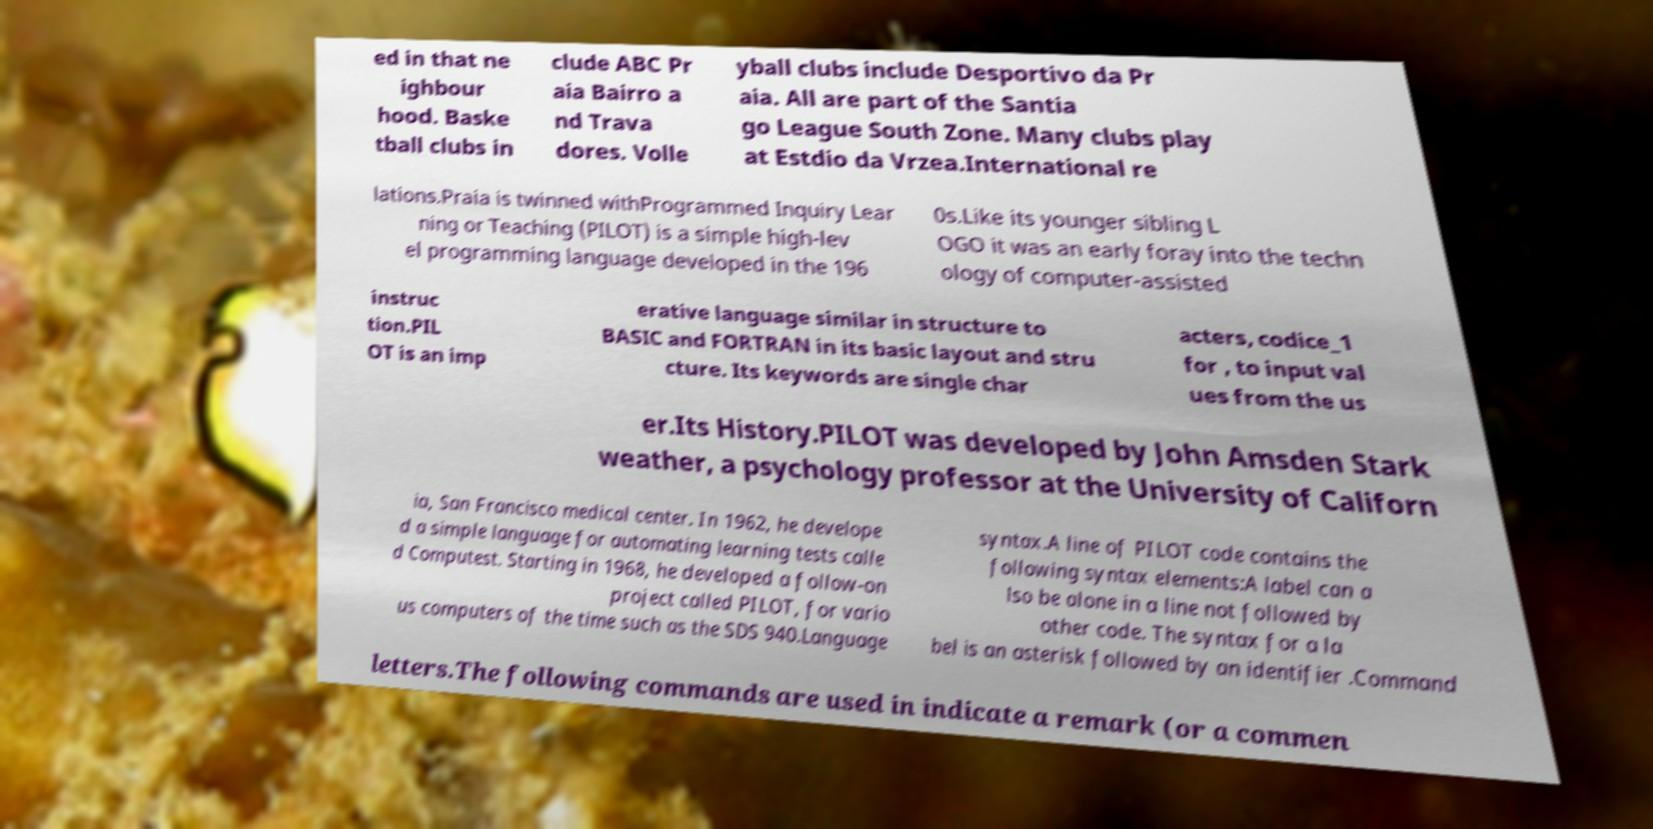Could you extract and type out the text from this image? ed in that ne ighbour hood. Baske tball clubs in clude ABC Pr aia Bairro a nd Trava dores. Volle yball clubs include Desportivo da Pr aia. All are part of the Santia go League South Zone. Many clubs play at Estdio da Vrzea.International re lations.Praia is twinned withProgrammed Inquiry Lear ning or Teaching (PILOT) is a simple high-lev el programming language developed in the 196 0s.Like its younger sibling L OGO it was an early foray into the techn ology of computer-assisted instruc tion.PIL OT is an imp erative language similar in structure to BASIC and FORTRAN in its basic layout and stru cture. Its keywords are single char acters, codice_1 for , to input val ues from the us er.Its History.PILOT was developed by John Amsden Stark weather, a psychology professor at the University of Californ ia, San Francisco medical center. In 1962, he develope d a simple language for automating learning tests calle d Computest. Starting in 1968, he developed a follow-on project called PILOT, for vario us computers of the time such as the SDS 940.Language syntax.A line of PILOT code contains the following syntax elements:A label can a lso be alone in a line not followed by other code. The syntax for a la bel is an asterisk followed by an identifier .Command letters.The following commands are used in indicate a remark (or a commen 